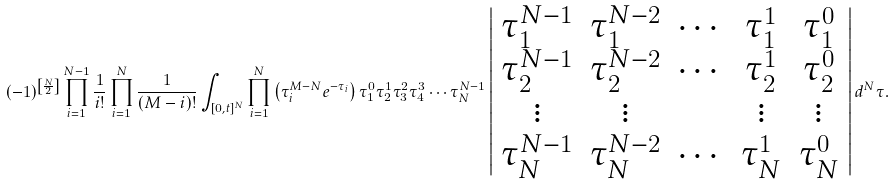<formula> <loc_0><loc_0><loc_500><loc_500>( - 1 ) ^ { \left [ \frac { N } { 2 } \right ] } \prod _ { i = 1 } ^ { N - 1 } \frac { 1 } { i ! } \prod _ { i = 1 } ^ { N } \frac { 1 } { ( M - i ) ! } \int _ { [ 0 , t ] ^ { N } } \prod _ { i = 1 } ^ { N } \left ( \tau _ { i } ^ { M - N } e ^ { - \tau _ { i } } \right ) \tau _ { 1 } ^ { 0 } \tau _ { 2 } ^ { 1 } \tau _ { 3 } ^ { 2 } \tau _ { 4 } ^ { 3 } \cdots \tau _ { N } ^ { N - 1 } \left | \begin{array} { c c c c c } \tau _ { 1 } ^ { N - 1 } & \tau _ { 1 } ^ { N - 2 } & \cdots & \tau _ { 1 } ^ { 1 } & \tau _ { 1 } ^ { 0 } \\ \tau _ { 2 } ^ { N - 1 } & \tau _ { 2 } ^ { N - 2 } & \cdots & \tau _ { 2 } ^ { 1 } & \tau _ { 2 } ^ { 0 } \\ \vdots & \vdots & & \vdots & \vdots \\ \tau _ { N } ^ { N - 1 } & \tau _ { N } ^ { N - 2 } & \cdots & \tau _ { N } ^ { 1 } & \tau _ { N } ^ { 0 } \\ \end{array} \right | d ^ { N } \tau .</formula> 